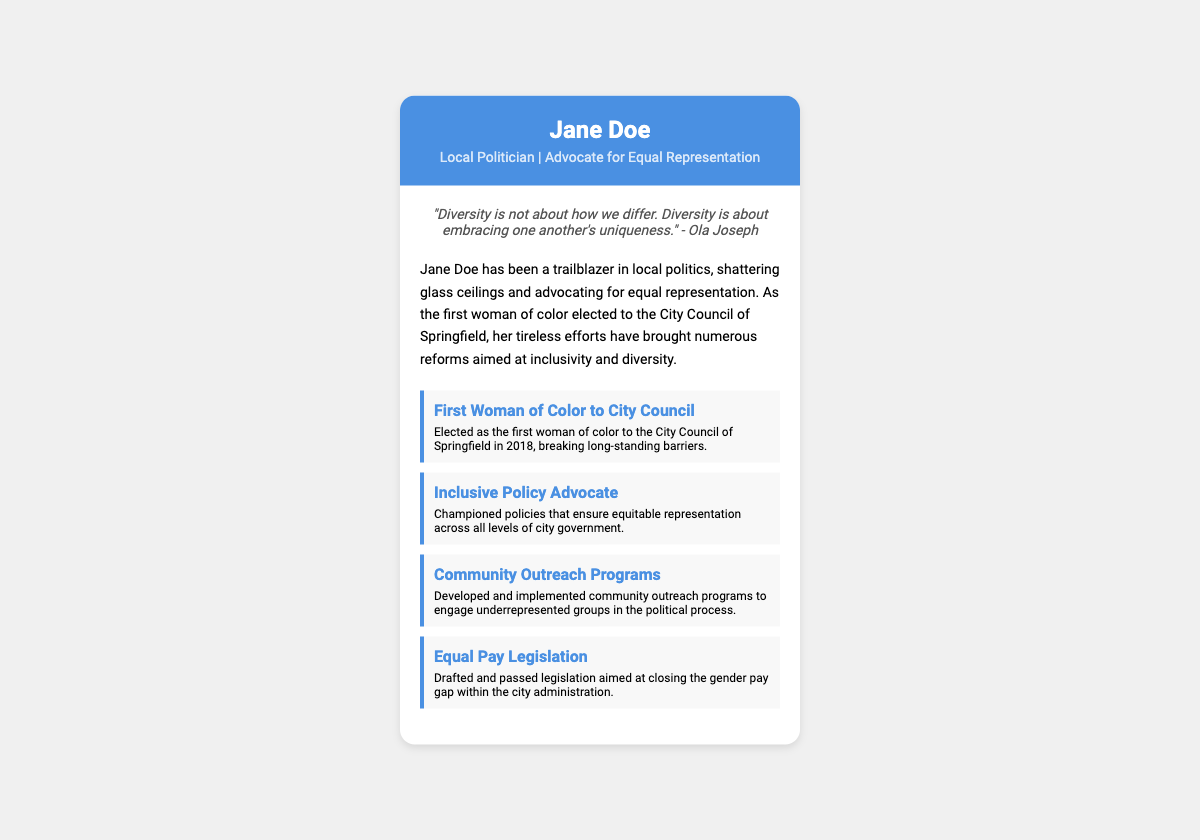What is the name of the politician? The name of the politician is prominently displayed at the top of the card.
Answer: Jane Doe What quote is featured on the card? The card includes a specific quote about diversity, located in the quote section.
Answer: "Diversity is not about how we differ. Diversity is about embracing one another's uniqueness." - Ola Joseph In which year was Jane Doe elected to the City Council? The document states the year Jane Doe was elected, which is mentioned in her achievements.
Answer: 2018 What is one of Jane Doe's roles regarding policy? The achievements section highlights her advocacy for specific policies in city government.
Answer: Inclusive Policy Advocate What legislation did Jane Doe draft? The document lists specific legislation that Jane Doe has worked on concerning pay.
Answer: Equal Pay Legislation Which city council is Jane Doe a member of? Her affiliation is stated under her title on the business card itself.
Answer: City Council of Springfield How does Jane Doe engage with underrepresented groups? The document mentions a specific type of program she developed for engagement.
Answer: Community Outreach Programs What color scheme is used in the header of the card? The color of the header is described clearly in the styled portion of the document.
Answer: Blue 